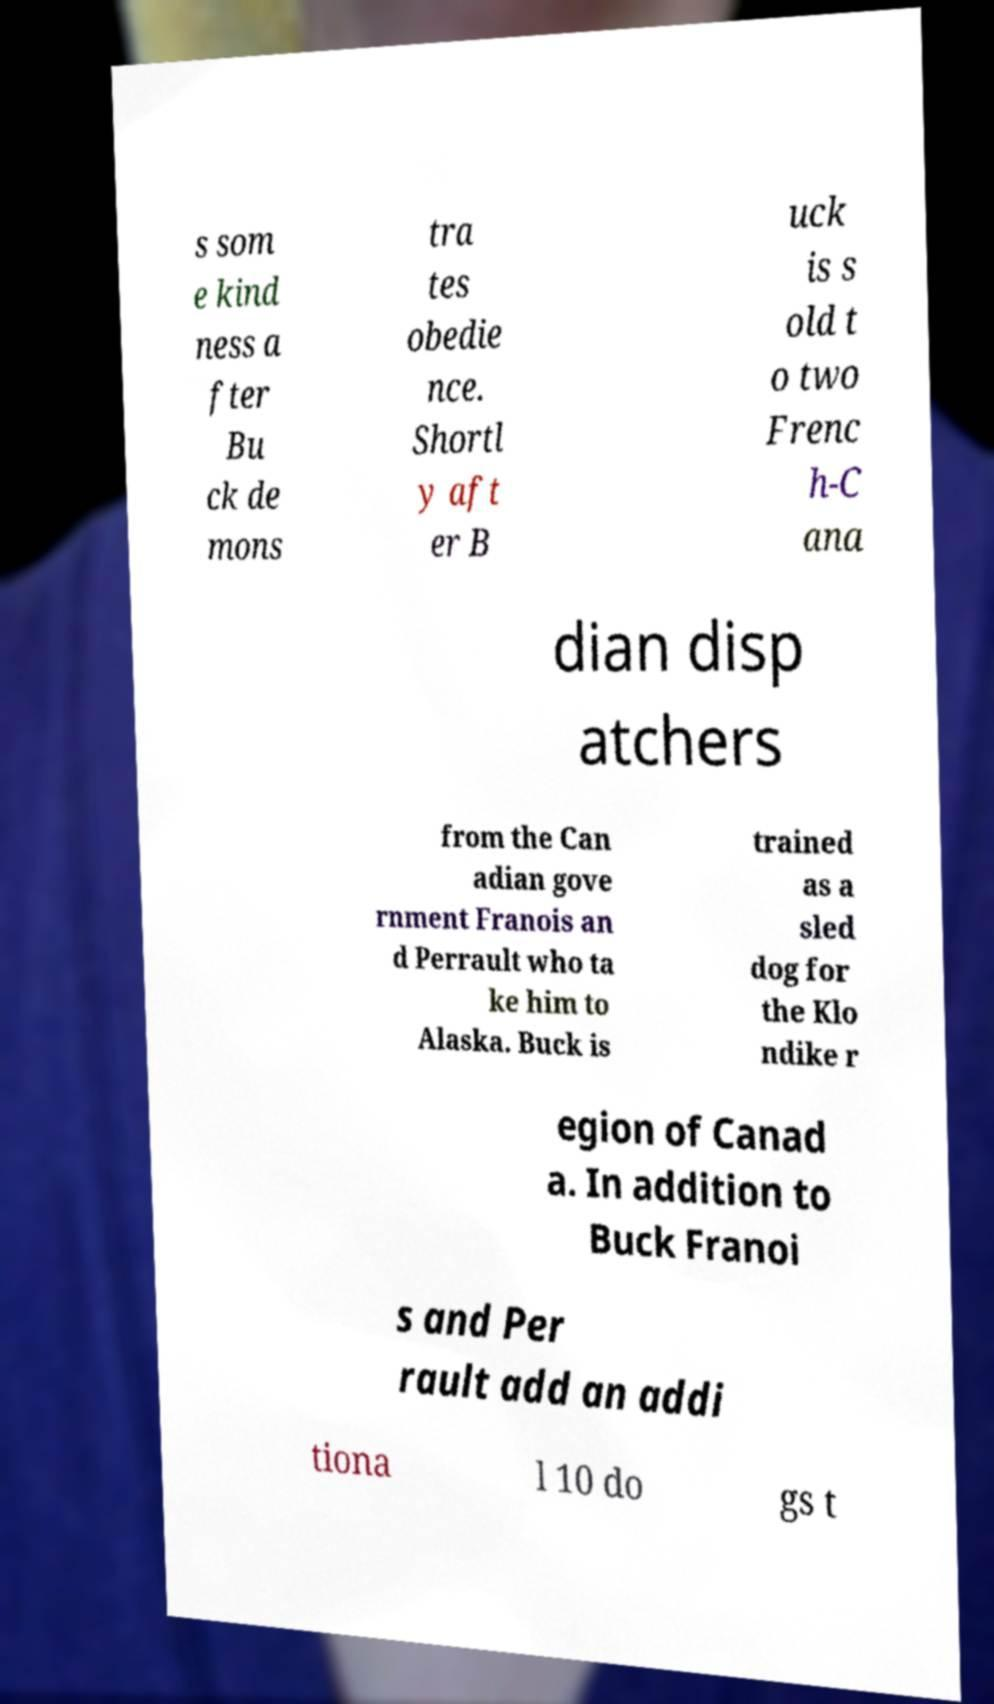Could you extract and type out the text from this image? s som e kind ness a fter Bu ck de mons tra tes obedie nce. Shortl y aft er B uck is s old t o two Frenc h-C ana dian disp atchers from the Can adian gove rnment Franois an d Perrault who ta ke him to Alaska. Buck is trained as a sled dog for the Klo ndike r egion of Canad a. In addition to Buck Franoi s and Per rault add an addi tiona l 10 do gs t 